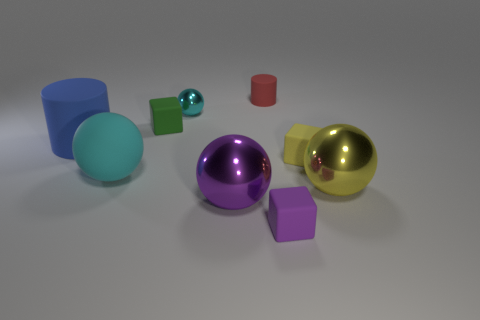Subtract 1 blocks. How many blocks are left? 2 Subtract all green spheres. Subtract all green cubes. How many spheres are left? 4 Subtract all cylinders. How many objects are left? 7 Add 4 rubber balls. How many rubber balls are left? 5 Add 8 yellow cubes. How many yellow cubes exist? 9 Subtract 1 yellow balls. How many objects are left? 8 Subtract all small blue cylinders. Subtract all tiny matte blocks. How many objects are left? 6 